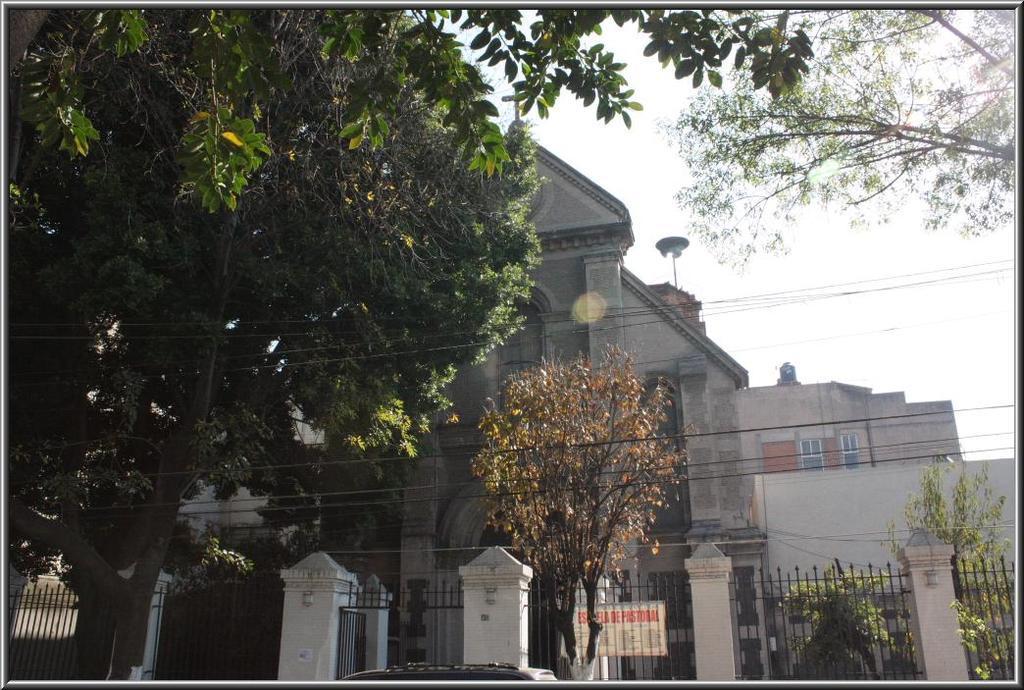In one or two sentences, can you explain what this image depicts? This is the picture of a place where have some buildings and to the side we can see a fencing to which there is a board and also we can see some trees and plants. 